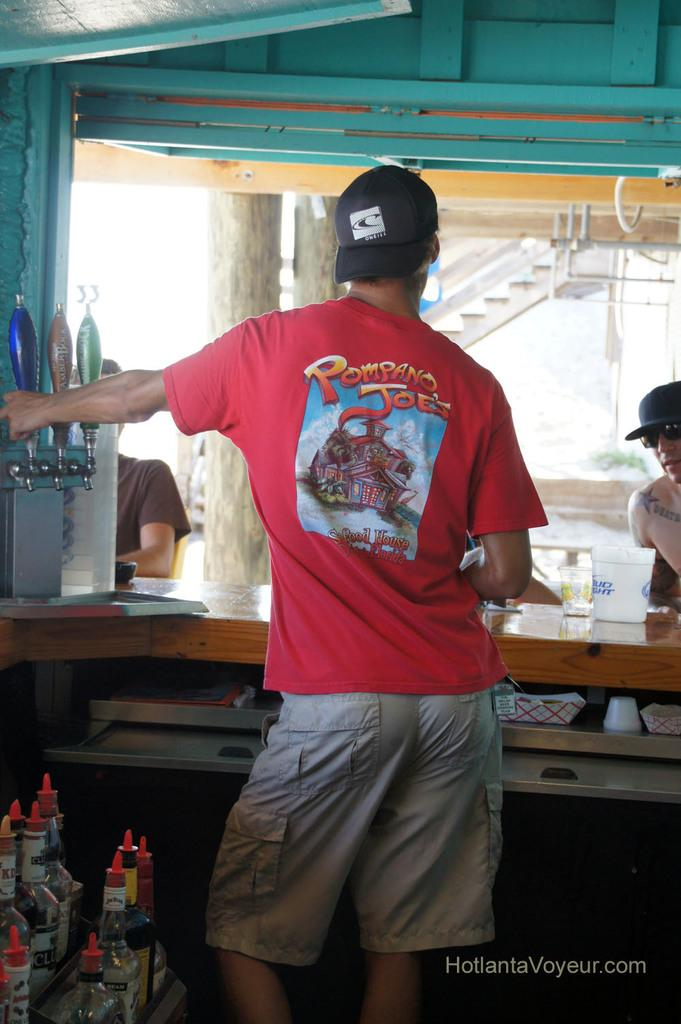What is the main subject in the image? There is a person standing in the image. What can be seen in the foreground of the image? There are toys in the foreground of the image. What is visible in the background of the image? There are people, other objects, stairs, and a roof in the background of the image. What type of ship can be seen sailing in the background of the image? There is no ship visible in the image; it only features a person, toys, and various objects, people, stairs, and a roof in the background. 